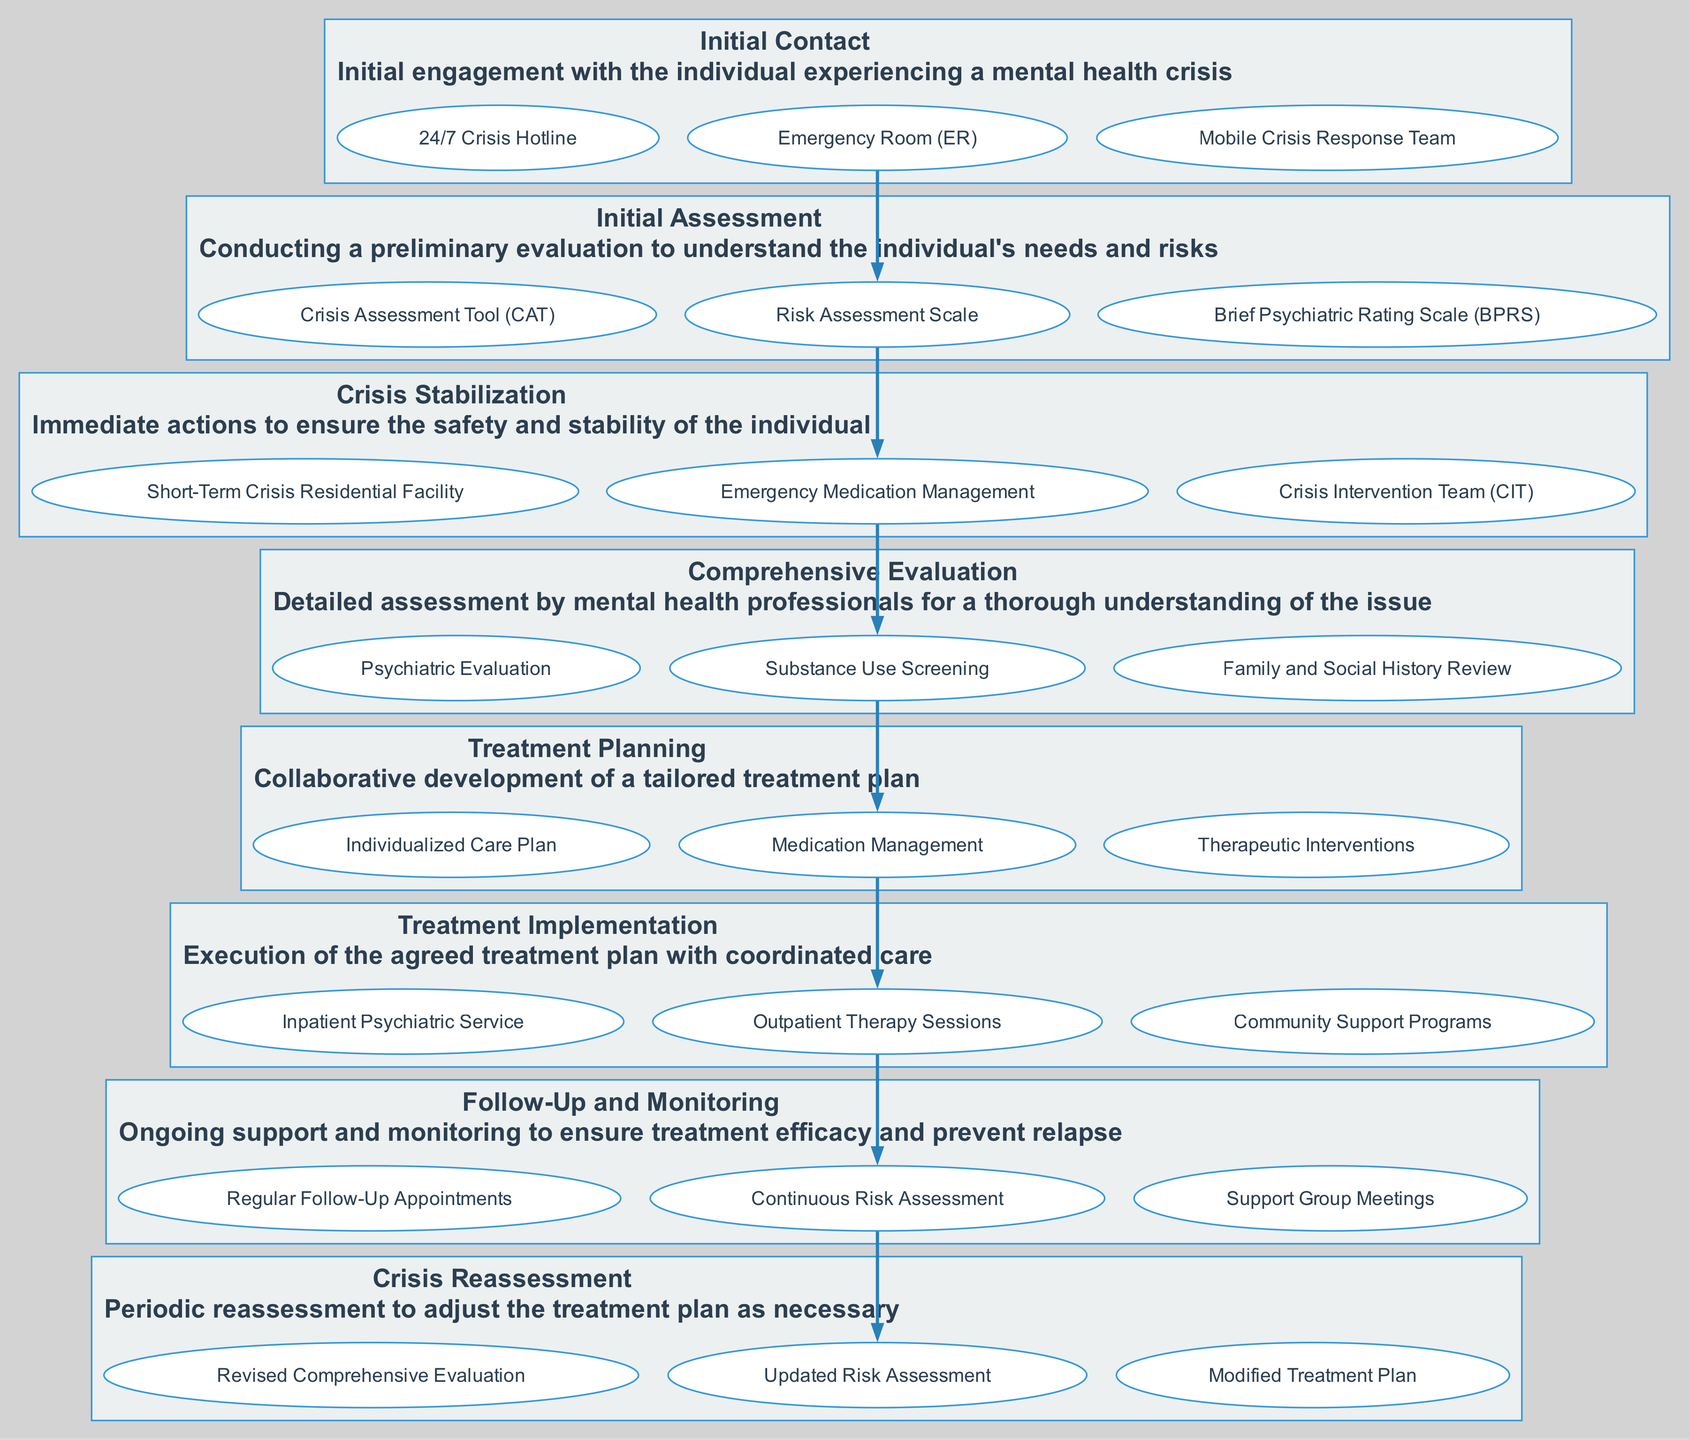What is the first step in the pathway? The first step, as indicated in the diagram, is named "Initial Contact". This is the initial engagement with the individual experiencing a mental health crisis.
Answer: Initial Contact How many entities are linked to the "Crisis Stabilization" step? The "Crisis Stabilization" step has three entities associated with it, as shown in the diagram. These are vital components that describe actions taken during this phase.
Answer: 3 What step follows "Comprehensive Evaluation"? According to the flow of the diagram, the step that directly follows "Comprehensive Evaluation" is "Treatment Planning". This indicates the progression of care in the clinical pathway.
Answer: Treatment Planning Which entities are associated with "Follow-Up and Monitoring"? The entities related to "Follow-Up and Monitoring" are "Regular Follow-Up Appointments", "Continuous Risk Assessment", and "Support Group Meetings". These indicate the ongoing support needed.
Answer: Regular Follow-Up Appointments, Continuous Risk Assessment, Support Group Meetings What is the last step in the clinical pathway? The diagram indicates that the last step in the clinical pathway is "Crisis Reassessment". This is crucial as it involves periodic reassessment to adjust the treatment plan as necessary.
Answer: Crisis Reassessment What type of assessment is conducted during "Initial Assessment"? During "Initial Assessment", a "Crisis Assessment Tool (CAT)" is used along with other scales to conduct a preliminary evaluation for understanding needs and risks.
Answer: Crisis Assessment Tool (CAT) What is the purpose of the "Treatment Implementation" step? The purpose of "Treatment Implementation" is the execution of the agreed treatment plan with coordinated care, as described in its section within the diagram.
Answer: Execution of the agreed treatment plan How many steps are listed in the pathway? The diagram lists a total of eight steps in the clinical pathway, which outlines the process from initial contact through follow-up treatment.
Answer: 8 What is the significance of "Emergency Room (ER)" in the pathway? The "Emergency Room (ER)" is one of the entities linked to the "Initial Contact" step, indicating that it is a critical point for initial engagement in a mental health crisis intervention.
Answer: Critical point for initial engagement 